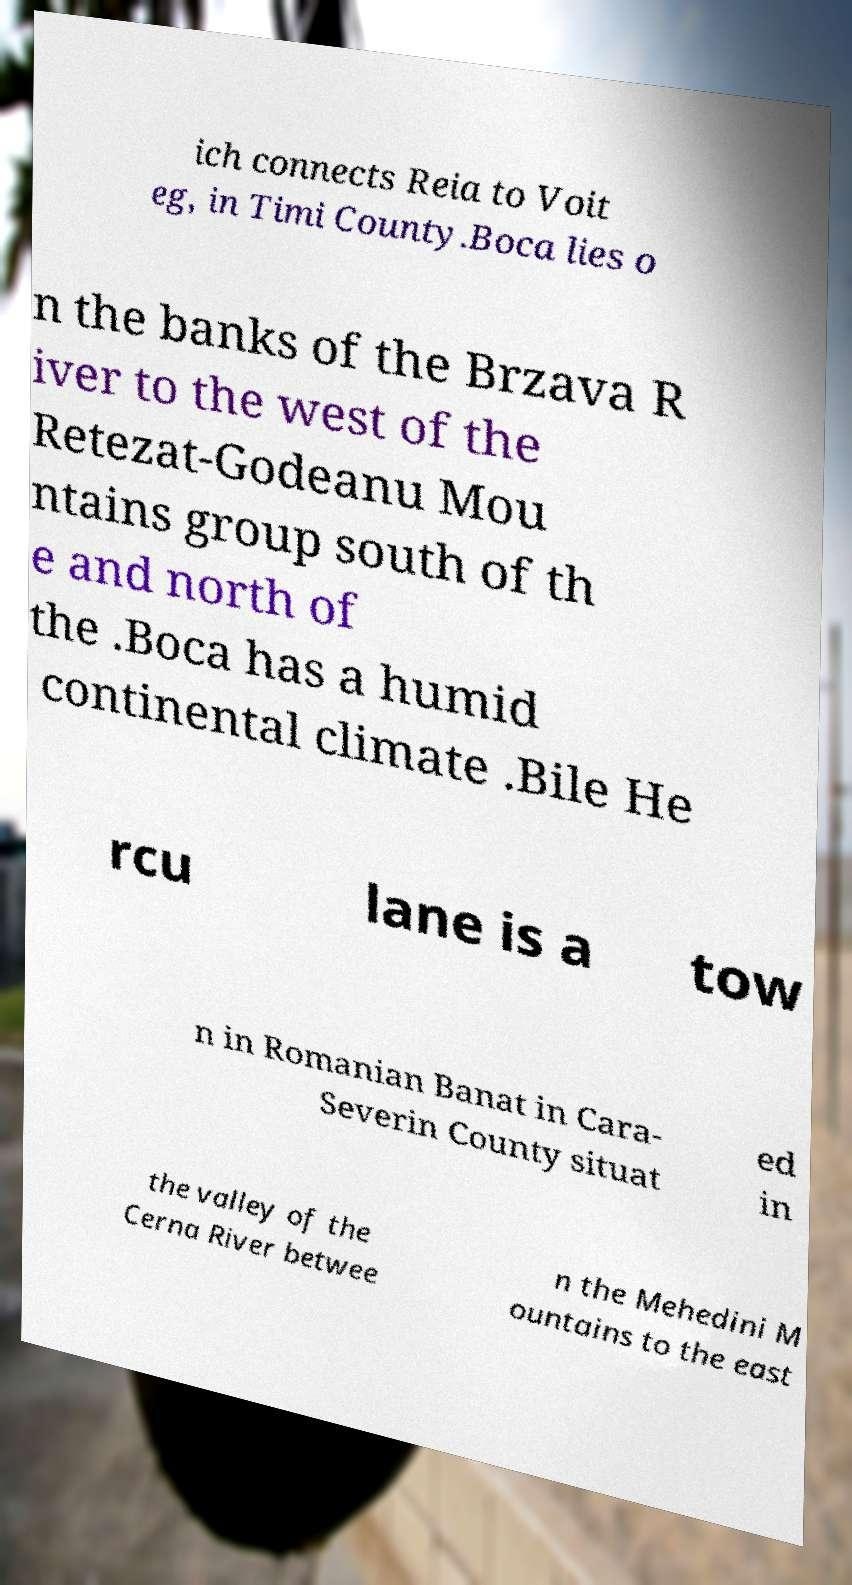Please identify and transcribe the text found in this image. ich connects Reia to Voit eg, in Timi County.Boca lies o n the banks of the Brzava R iver to the west of the Retezat-Godeanu Mou ntains group south of th e and north of the .Boca has a humid continental climate .Bile He rcu lane is a tow n in Romanian Banat in Cara- Severin County situat ed in the valley of the Cerna River betwee n the Mehedini M ountains to the east 